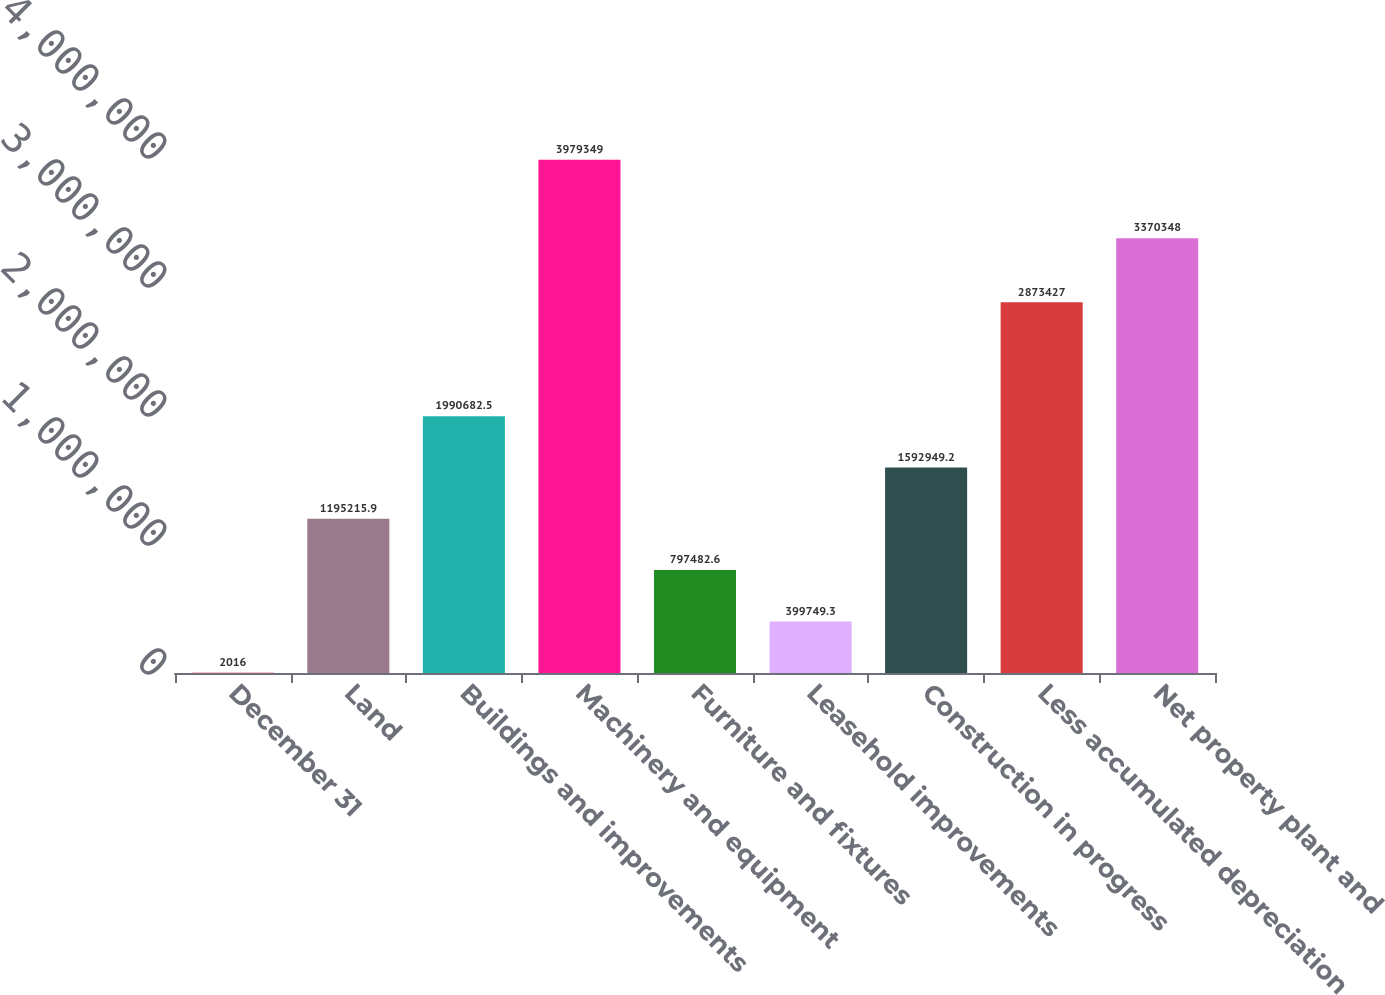Convert chart to OTSL. <chart><loc_0><loc_0><loc_500><loc_500><bar_chart><fcel>December 31<fcel>Land<fcel>Buildings and improvements<fcel>Machinery and equipment<fcel>Furniture and fixtures<fcel>Leasehold improvements<fcel>Construction in progress<fcel>Less accumulated depreciation<fcel>Net property plant and<nl><fcel>2016<fcel>1.19522e+06<fcel>1.99068e+06<fcel>3.97935e+06<fcel>797483<fcel>399749<fcel>1.59295e+06<fcel>2.87343e+06<fcel>3.37035e+06<nl></chart> 